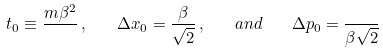<formula> <loc_0><loc_0><loc_500><loc_500>t _ { 0 } \equiv \frac { m \beta ^ { 2 } } { } \, , \quad \Delta x _ { 0 } = \frac { \beta } { \sqrt { 2 } } \, , \quad a n d \quad \Delta p _ { 0 } = \frac { } { \beta \sqrt { 2 } }</formula> 